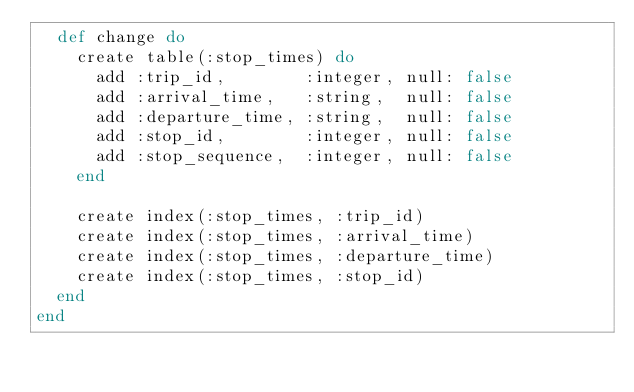Convert code to text. <code><loc_0><loc_0><loc_500><loc_500><_Elixir_>  def change do
    create table(:stop_times) do
      add :trip_id,        :integer, null: false
      add :arrival_time,   :string,  null: false
      add :departure_time, :string,  null: false
      add :stop_id,        :integer, null: false
      add :stop_sequence,  :integer, null: false
    end

    create index(:stop_times, :trip_id)
    create index(:stop_times, :arrival_time)
    create index(:stop_times, :departure_time)
    create index(:stop_times, :stop_id)
  end
end
</code> 